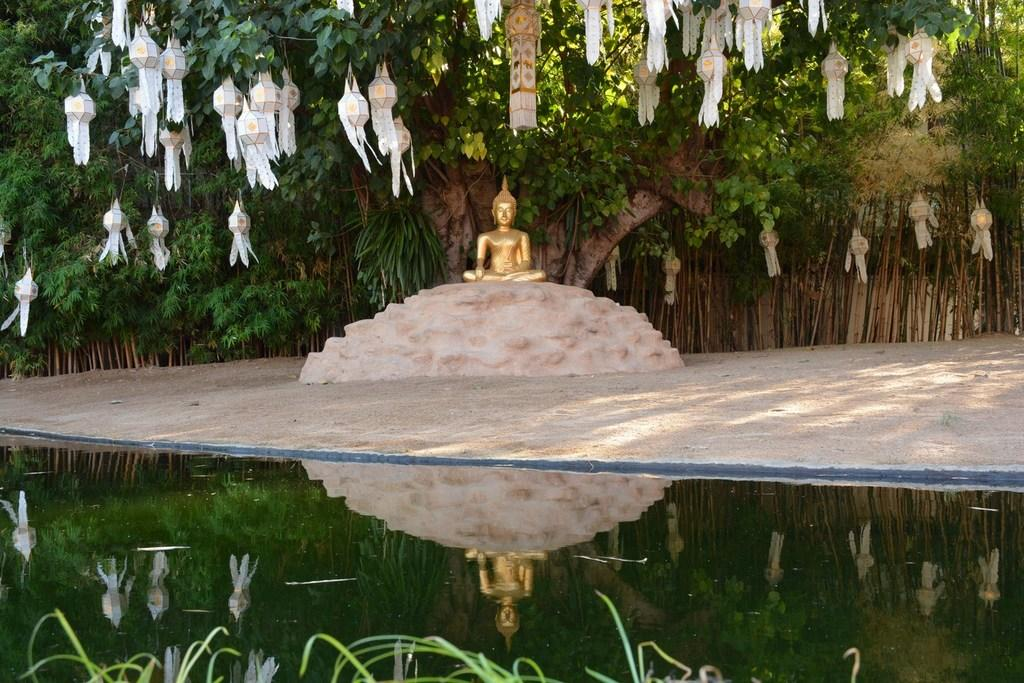What is the primary element visible in the image? There is water in the image. What type of structure can be seen in the image? There is a statue in the image. What type of lighting is present in the image? There are lamps in the image. What can be seen in the background of the image? There are trees in the background of the image. Can you tell me how many firemen are standing next to the statue in the image? There are no firemen present in the image; it only features a statue, water, lamps, and trees. 